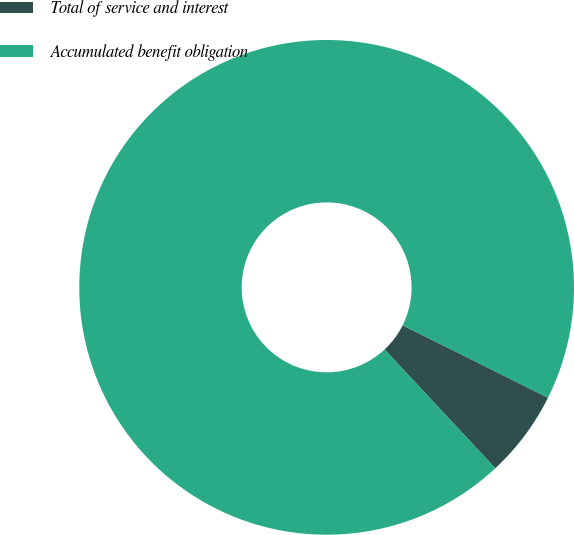<chart> <loc_0><loc_0><loc_500><loc_500><pie_chart><fcel>Total of service and interest<fcel>Accumulated benefit obligation<nl><fcel>5.7%<fcel>94.3%<nl></chart> 